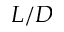Convert formula to latex. <formula><loc_0><loc_0><loc_500><loc_500>L / D</formula> 